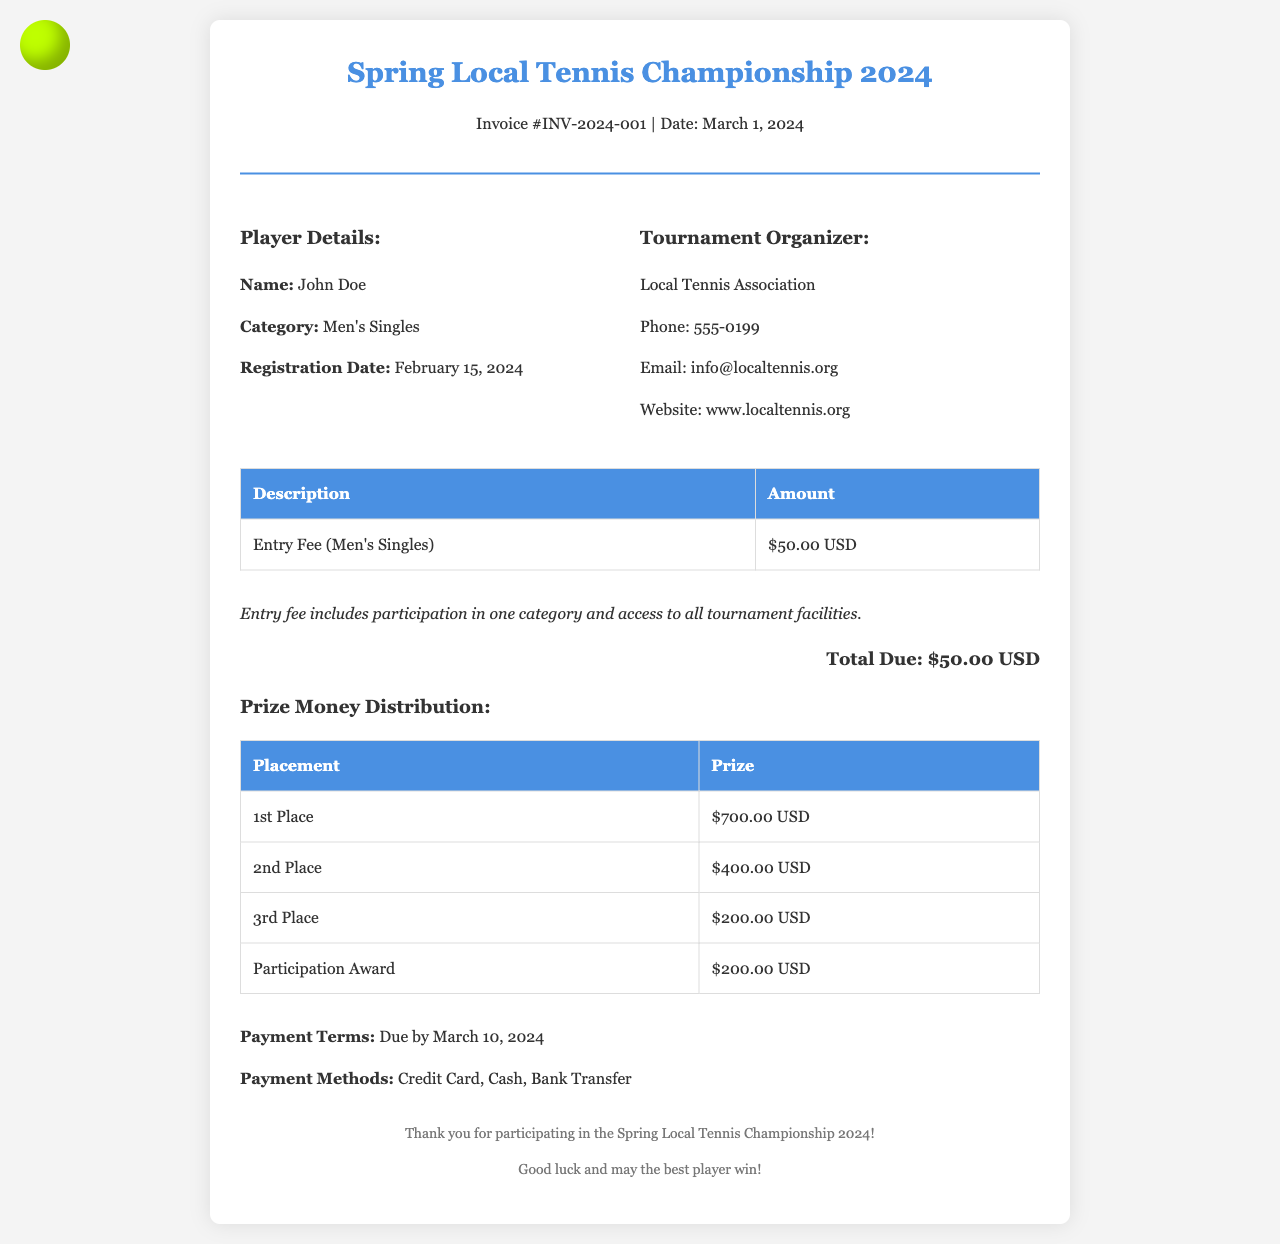What is the name of the player? The player's name is specified in the document under Player Details.
Answer: John Doe What is the entry fee? The entry fee amount is listed in the invoice details section under the description of the entry fee.
Answer: $50.00 USD What category is John Doe competing in? The player's category is mentioned in the Player Details section of the document.
Answer: Men's Singles What is the total due amount? The total amount due is stated in the total section of the invoice.
Answer: $50.00 USD When is the payment due? The payment due date is expressed in the Payment Terms section of the invoice.
Answer: March 10, 2024 What are the prize amounts for the top three placements? The prize distribution for placements is highlighted in the Prize Money Distribution table, listing the respective amounts.
Answer: $700.00 USD, $400.00 USD, $200.00 USD What organization is hosting the tournament? The tournament organizer's name is provided in the invoice details.
Answer: Local Tennis Association How can payments be made? The payment methods are outlined under the Payment Methods section of the invoice.
Answer: Credit Card, Cash, Bank Transfer 